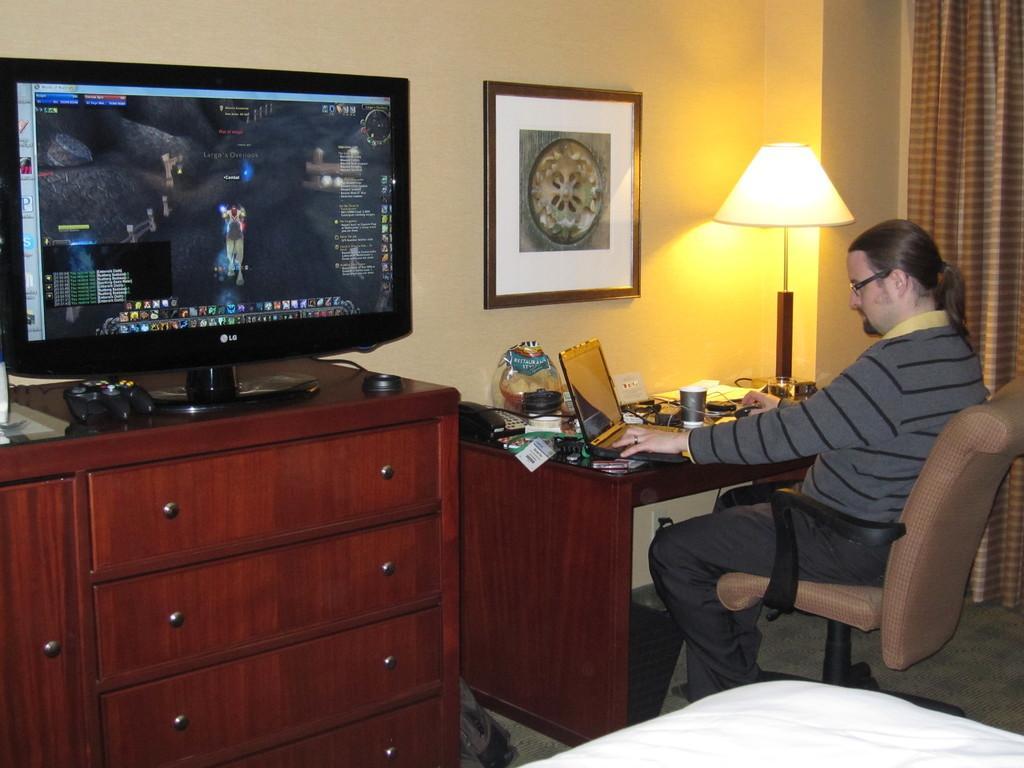How would you summarize this image in a sentence or two? In this picture we can see a man who is sitting on the chair. This is table. On the table there is a lamp, glass, and a laptop. This is cupboard and there is a screen. On the background there is a wall and this is frame. Here we can see a curtain. 